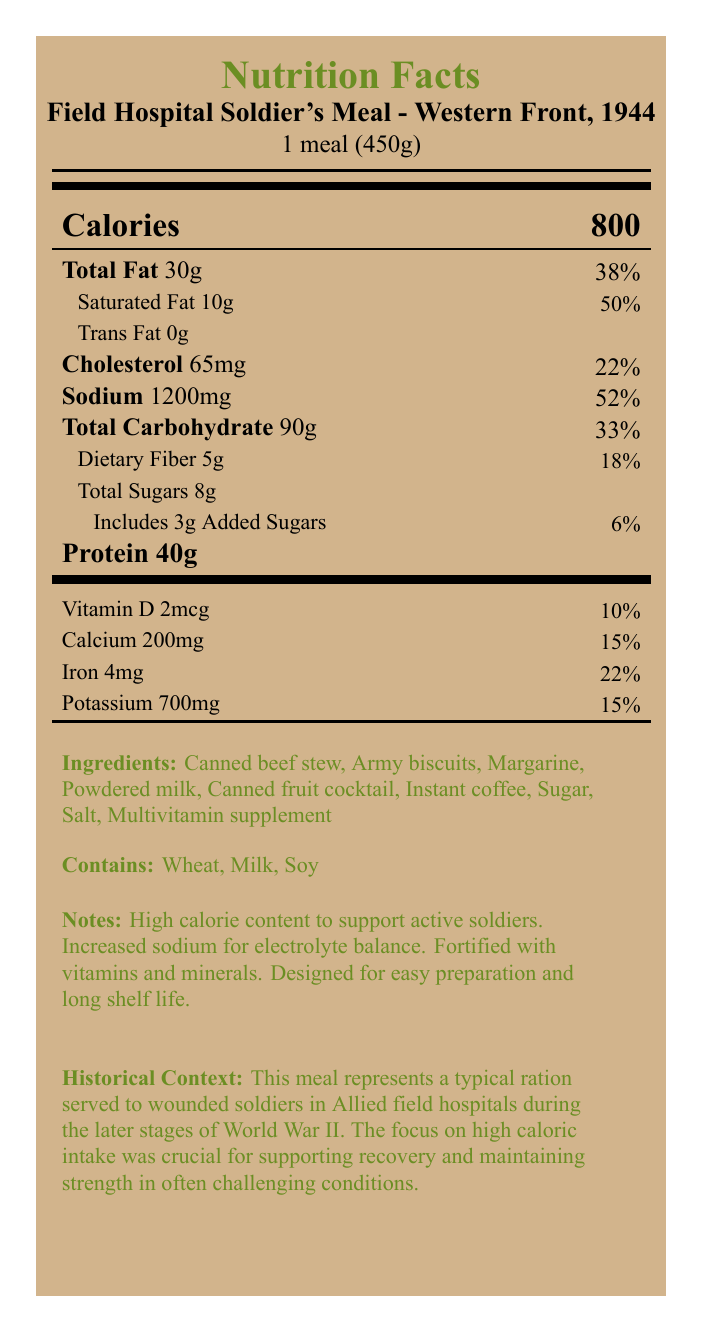What is the caloric content of the Field Hospital Soldier's Meal? The document states "Calories 800" prominently.
Answer: 800 calories What is the serving size for this meal? The document defines the serving size as "1 meal (450g)" under the product name.
Answer: 1 meal (450g) How much protein does the meal contain? The label lists "Protein 40g" clearly.
Answer: 40g What percentage of the daily value of saturated fat is in the meal? The document shows "Saturated Fat 10g, 50%".
Answer: 50% Which vitamin is added to the meal, and how much? The document lists "Vitamin D 2mcg, 10%" under nutritional information.
Answer: Vitamin D, 2mcg What are the main ingredients in the meal? The ingredients are specified in the "Ingredients" section of the nutrition facts label.
Answer: Canned beef stew, Army biscuits, Margarine, Powdered milk, Canned fruit cocktail, Instant coffee, Sugar, Salt, Multivitamin supplement What is the sodium content in the meal? The document lists "Sodium 1200mg, 52%" under nutritional information.
Answer: 1200mg What is the historical context mentioned for this meal? The historical context section explains this purpose.
Answer: It was designed for use in Allied field hospitals during the late stages of World War II to support recovery and maintain strength in challenging conditions. What is the main goal of this meal according to the nutritional notes? These points are highlighted in the "Notes" section of the label.
Answer: High caloric content to support active soldiers, increased sodium for electrolyte balance, fortified with vitamins and minerals, designed for easy preparation and long shelf life Which of these is not an allergen present in the meal? A. Wheat B. Milk C. Soy D. Peanuts The label mentions Wheat, Milk, Soy but not Peanuts in the "Contains" section.
Answer: D. Peanuts How many grams of dietary fiber are in the meal? A. 3g B. 4g C. 5g D. 6g The document lists "Dietary Fiber 5g, 18%" under nutritional information.
Answer: C. 5g Does the meal contain trans fats? The document clearly states "Trans Fat 0g".
Answer: No Summarize the purpose and design of the Field Hospital Soldier's Meal. The document outlines these points under historical context and nutritional notes.
Answer: This meal, used in Allied field hospitals during World War II, provides high energy and essential nutrients to wounded soldiers. It emphasizes high caloric intake for recovery, increased sodium for electrolyte balance, and a fortification of vitamins and minerals. The meal is designed for easy preparation and long shelf life. What were the main operational theaters where this meal was used? The document does not specify particular operational theaters beyond general Allied field hospitals in 1944.
Answer: Not enough information 